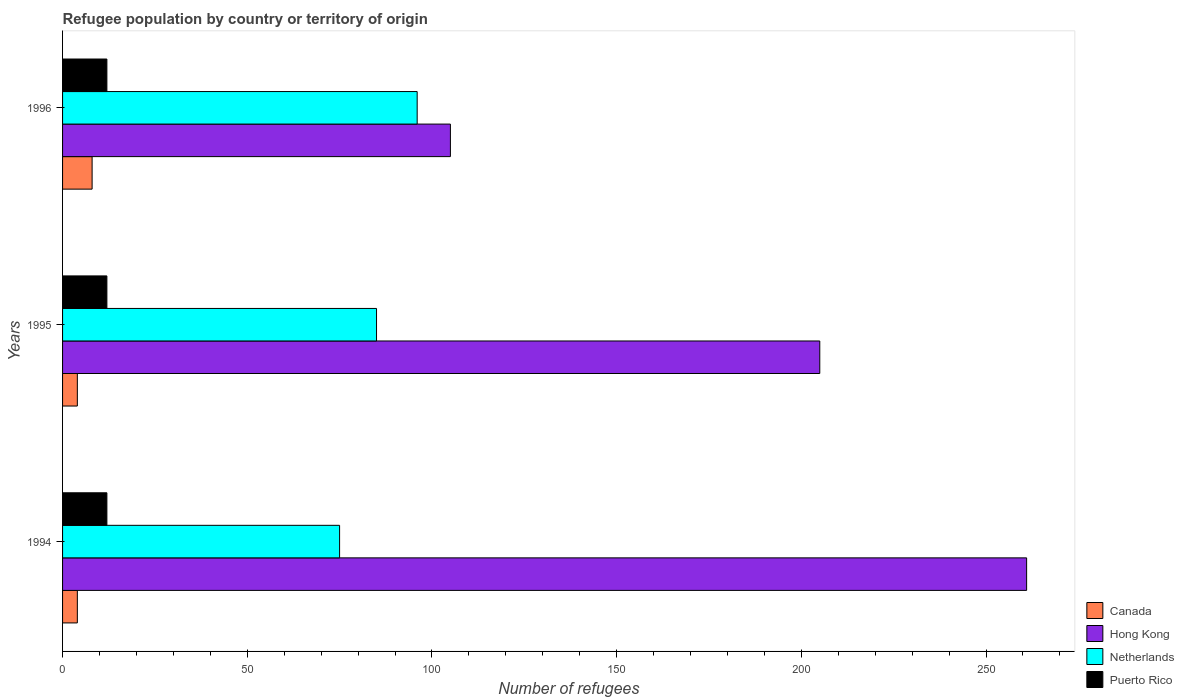How many different coloured bars are there?
Make the answer very short. 4. Are the number of bars per tick equal to the number of legend labels?
Your answer should be compact. Yes. Are the number of bars on each tick of the Y-axis equal?
Your answer should be compact. Yes. How many bars are there on the 1st tick from the top?
Your response must be concise. 4. How many bars are there on the 3rd tick from the bottom?
Your response must be concise. 4. What is the label of the 3rd group of bars from the top?
Offer a terse response. 1994. What is the number of refugees in Puerto Rico in 1995?
Make the answer very short. 12. Across all years, what is the minimum number of refugees in Netherlands?
Your answer should be compact. 75. In which year was the number of refugees in Hong Kong minimum?
Provide a succinct answer. 1996. What is the difference between the number of refugees in Canada in 1994 and that in 1995?
Your answer should be very brief. 0. What is the difference between the number of refugees in Canada in 1994 and the number of refugees in Hong Kong in 1996?
Offer a terse response. -101. What is the average number of refugees in Hong Kong per year?
Keep it short and to the point. 190.33. In the year 1994, what is the difference between the number of refugees in Hong Kong and number of refugees in Canada?
Provide a short and direct response. 257. In how many years, is the number of refugees in Puerto Rico greater than the average number of refugees in Puerto Rico taken over all years?
Offer a very short reply. 0. Is it the case that in every year, the sum of the number of refugees in Hong Kong and number of refugees in Puerto Rico is greater than the sum of number of refugees in Canada and number of refugees in Netherlands?
Your answer should be very brief. Yes. What does the 1st bar from the top in 1994 represents?
Offer a very short reply. Puerto Rico. What does the 2nd bar from the bottom in 1994 represents?
Your answer should be very brief. Hong Kong. Is it the case that in every year, the sum of the number of refugees in Hong Kong and number of refugees in Puerto Rico is greater than the number of refugees in Netherlands?
Keep it short and to the point. Yes. Are all the bars in the graph horizontal?
Provide a short and direct response. Yes. Does the graph contain any zero values?
Make the answer very short. No. Does the graph contain grids?
Provide a succinct answer. No. Where does the legend appear in the graph?
Offer a terse response. Bottom right. How are the legend labels stacked?
Keep it short and to the point. Vertical. What is the title of the graph?
Your answer should be very brief. Refugee population by country or territory of origin. What is the label or title of the X-axis?
Give a very brief answer. Number of refugees. What is the label or title of the Y-axis?
Give a very brief answer. Years. What is the Number of refugees in Canada in 1994?
Give a very brief answer. 4. What is the Number of refugees in Hong Kong in 1994?
Your answer should be very brief. 261. What is the Number of refugees in Netherlands in 1994?
Give a very brief answer. 75. What is the Number of refugees in Puerto Rico in 1994?
Offer a terse response. 12. What is the Number of refugees of Canada in 1995?
Your answer should be compact. 4. What is the Number of refugees in Hong Kong in 1995?
Your answer should be very brief. 205. What is the Number of refugees in Puerto Rico in 1995?
Offer a terse response. 12. What is the Number of refugees of Canada in 1996?
Offer a very short reply. 8. What is the Number of refugees of Hong Kong in 1996?
Your response must be concise. 105. What is the Number of refugees of Netherlands in 1996?
Provide a succinct answer. 96. What is the Number of refugees of Puerto Rico in 1996?
Provide a succinct answer. 12. Across all years, what is the maximum Number of refugees of Canada?
Offer a very short reply. 8. Across all years, what is the maximum Number of refugees of Hong Kong?
Give a very brief answer. 261. Across all years, what is the maximum Number of refugees in Netherlands?
Offer a very short reply. 96. Across all years, what is the maximum Number of refugees of Puerto Rico?
Provide a short and direct response. 12. Across all years, what is the minimum Number of refugees in Hong Kong?
Make the answer very short. 105. Across all years, what is the minimum Number of refugees of Puerto Rico?
Ensure brevity in your answer.  12. What is the total Number of refugees in Canada in the graph?
Offer a terse response. 16. What is the total Number of refugees in Hong Kong in the graph?
Offer a terse response. 571. What is the total Number of refugees in Netherlands in the graph?
Your response must be concise. 256. What is the difference between the Number of refugees of Canada in 1994 and that in 1995?
Offer a very short reply. 0. What is the difference between the Number of refugees in Hong Kong in 1994 and that in 1995?
Your answer should be compact. 56. What is the difference between the Number of refugees of Netherlands in 1994 and that in 1995?
Your answer should be compact. -10. What is the difference between the Number of refugees in Puerto Rico in 1994 and that in 1995?
Your response must be concise. 0. What is the difference between the Number of refugees in Hong Kong in 1994 and that in 1996?
Provide a succinct answer. 156. What is the difference between the Number of refugees of Netherlands in 1994 and that in 1996?
Provide a short and direct response. -21. What is the difference between the Number of refugees of Puerto Rico in 1994 and that in 1996?
Provide a succinct answer. 0. What is the difference between the Number of refugees in Puerto Rico in 1995 and that in 1996?
Provide a short and direct response. 0. What is the difference between the Number of refugees in Canada in 1994 and the Number of refugees in Hong Kong in 1995?
Offer a very short reply. -201. What is the difference between the Number of refugees of Canada in 1994 and the Number of refugees of Netherlands in 1995?
Keep it short and to the point. -81. What is the difference between the Number of refugees of Hong Kong in 1994 and the Number of refugees of Netherlands in 1995?
Provide a short and direct response. 176. What is the difference between the Number of refugees of Hong Kong in 1994 and the Number of refugees of Puerto Rico in 1995?
Provide a short and direct response. 249. What is the difference between the Number of refugees of Netherlands in 1994 and the Number of refugees of Puerto Rico in 1995?
Offer a terse response. 63. What is the difference between the Number of refugees in Canada in 1994 and the Number of refugees in Hong Kong in 1996?
Provide a succinct answer. -101. What is the difference between the Number of refugees of Canada in 1994 and the Number of refugees of Netherlands in 1996?
Your answer should be very brief. -92. What is the difference between the Number of refugees of Canada in 1994 and the Number of refugees of Puerto Rico in 1996?
Make the answer very short. -8. What is the difference between the Number of refugees of Hong Kong in 1994 and the Number of refugees of Netherlands in 1996?
Provide a succinct answer. 165. What is the difference between the Number of refugees in Hong Kong in 1994 and the Number of refugees in Puerto Rico in 1996?
Your response must be concise. 249. What is the difference between the Number of refugees in Netherlands in 1994 and the Number of refugees in Puerto Rico in 1996?
Your answer should be compact. 63. What is the difference between the Number of refugees in Canada in 1995 and the Number of refugees in Hong Kong in 1996?
Provide a succinct answer. -101. What is the difference between the Number of refugees in Canada in 1995 and the Number of refugees in Netherlands in 1996?
Offer a terse response. -92. What is the difference between the Number of refugees of Hong Kong in 1995 and the Number of refugees of Netherlands in 1996?
Your answer should be compact. 109. What is the difference between the Number of refugees in Hong Kong in 1995 and the Number of refugees in Puerto Rico in 1996?
Offer a terse response. 193. What is the average Number of refugees in Canada per year?
Ensure brevity in your answer.  5.33. What is the average Number of refugees of Hong Kong per year?
Ensure brevity in your answer.  190.33. What is the average Number of refugees of Netherlands per year?
Your response must be concise. 85.33. In the year 1994, what is the difference between the Number of refugees of Canada and Number of refugees of Hong Kong?
Provide a succinct answer. -257. In the year 1994, what is the difference between the Number of refugees in Canada and Number of refugees in Netherlands?
Provide a short and direct response. -71. In the year 1994, what is the difference between the Number of refugees in Canada and Number of refugees in Puerto Rico?
Your response must be concise. -8. In the year 1994, what is the difference between the Number of refugees in Hong Kong and Number of refugees in Netherlands?
Offer a very short reply. 186. In the year 1994, what is the difference between the Number of refugees of Hong Kong and Number of refugees of Puerto Rico?
Your answer should be compact. 249. In the year 1995, what is the difference between the Number of refugees in Canada and Number of refugees in Hong Kong?
Provide a succinct answer. -201. In the year 1995, what is the difference between the Number of refugees in Canada and Number of refugees in Netherlands?
Give a very brief answer. -81. In the year 1995, what is the difference between the Number of refugees in Canada and Number of refugees in Puerto Rico?
Offer a very short reply. -8. In the year 1995, what is the difference between the Number of refugees in Hong Kong and Number of refugees in Netherlands?
Offer a very short reply. 120. In the year 1995, what is the difference between the Number of refugees of Hong Kong and Number of refugees of Puerto Rico?
Offer a terse response. 193. In the year 1996, what is the difference between the Number of refugees of Canada and Number of refugees of Hong Kong?
Ensure brevity in your answer.  -97. In the year 1996, what is the difference between the Number of refugees of Canada and Number of refugees of Netherlands?
Provide a succinct answer. -88. In the year 1996, what is the difference between the Number of refugees of Hong Kong and Number of refugees of Netherlands?
Give a very brief answer. 9. In the year 1996, what is the difference between the Number of refugees of Hong Kong and Number of refugees of Puerto Rico?
Offer a terse response. 93. In the year 1996, what is the difference between the Number of refugees of Netherlands and Number of refugees of Puerto Rico?
Your response must be concise. 84. What is the ratio of the Number of refugees in Canada in 1994 to that in 1995?
Ensure brevity in your answer.  1. What is the ratio of the Number of refugees in Hong Kong in 1994 to that in 1995?
Give a very brief answer. 1.27. What is the ratio of the Number of refugees in Netherlands in 1994 to that in 1995?
Provide a short and direct response. 0.88. What is the ratio of the Number of refugees of Puerto Rico in 1994 to that in 1995?
Give a very brief answer. 1. What is the ratio of the Number of refugees in Canada in 1994 to that in 1996?
Your response must be concise. 0.5. What is the ratio of the Number of refugees of Hong Kong in 1994 to that in 1996?
Your response must be concise. 2.49. What is the ratio of the Number of refugees of Netherlands in 1994 to that in 1996?
Your answer should be compact. 0.78. What is the ratio of the Number of refugees of Hong Kong in 1995 to that in 1996?
Your answer should be compact. 1.95. What is the ratio of the Number of refugees of Netherlands in 1995 to that in 1996?
Offer a very short reply. 0.89. What is the difference between the highest and the second highest Number of refugees of Canada?
Keep it short and to the point. 4. What is the difference between the highest and the second highest Number of refugees in Puerto Rico?
Give a very brief answer. 0. What is the difference between the highest and the lowest Number of refugees of Hong Kong?
Provide a succinct answer. 156. What is the difference between the highest and the lowest Number of refugees in Puerto Rico?
Offer a very short reply. 0. 